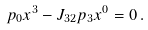<formula> <loc_0><loc_0><loc_500><loc_500>p _ { 0 } x ^ { 3 } - J _ { 3 2 } p _ { 3 } x ^ { 0 } = 0 \, .</formula> 